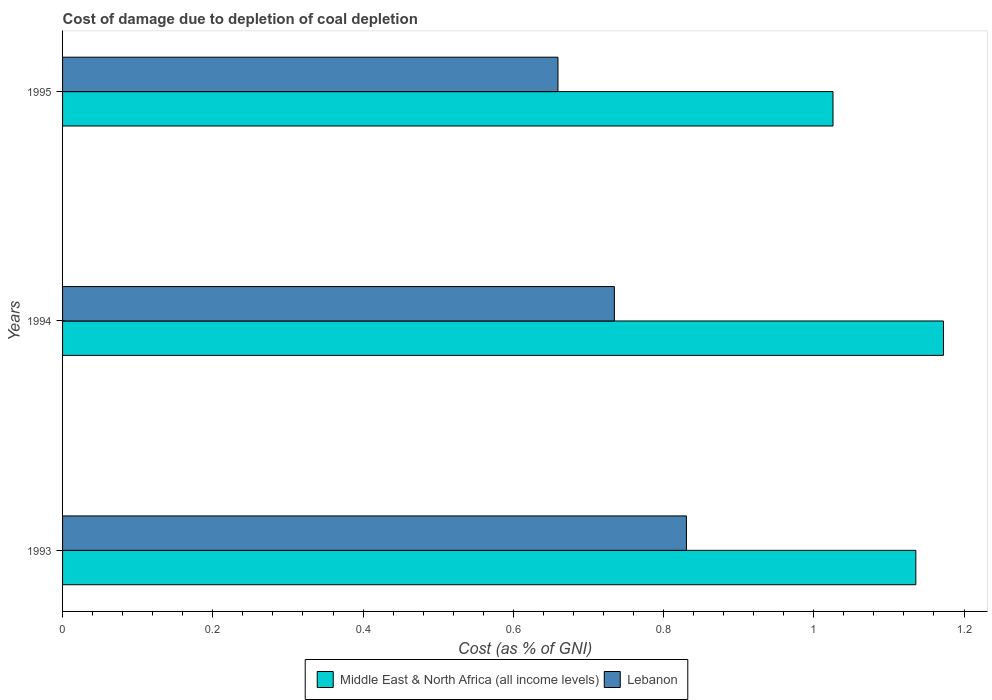How many different coloured bars are there?
Give a very brief answer. 2. How many groups of bars are there?
Make the answer very short. 3. How many bars are there on the 2nd tick from the top?
Provide a short and direct response. 2. What is the label of the 1st group of bars from the top?
Give a very brief answer. 1995. What is the cost of damage caused due to coal depletion in Middle East & North Africa (all income levels) in 1995?
Provide a succinct answer. 1.03. Across all years, what is the maximum cost of damage caused due to coal depletion in Middle East & North Africa (all income levels)?
Offer a very short reply. 1.17. Across all years, what is the minimum cost of damage caused due to coal depletion in Lebanon?
Offer a terse response. 0.66. In which year was the cost of damage caused due to coal depletion in Middle East & North Africa (all income levels) maximum?
Ensure brevity in your answer.  1994. What is the total cost of damage caused due to coal depletion in Middle East & North Africa (all income levels) in the graph?
Your answer should be very brief. 3.33. What is the difference between the cost of damage caused due to coal depletion in Middle East & North Africa (all income levels) in 1994 and that in 1995?
Your response must be concise. 0.15. What is the difference between the cost of damage caused due to coal depletion in Lebanon in 1993 and the cost of damage caused due to coal depletion in Middle East & North Africa (all income levels) in 1994?
Your answer should be compact. -0.34. What is the average cost of damage caused due to coal depletion in Lebanon per year?
Keep it short and to the point. 0.74. In the year 1995, what is the difference between the cost of damage caused due to coal depletion in Middle East & North Africa (all income levels) and cost of damage caused due to coal depletion in Lebanon?
Offer a very short reply. 0.37. What is the ratio of the cost of damage caused due to coal depletion in Middle East & North Africa (all income levels) in 1994 to that in 1995?
Your answer should be compact. 1.14. What is the difference between the highest and the second highest cost of damage caused due to coal depletion in Lebanon?
Keep it short and to the point. 0.1. What is the difference between the highest and the lowest cost of damage caused due to coal depletion in Lebanon?
Keep it short and to the point. 0.17. In how many years, is the cost of damage caused due to coal depletion in Middle East & North Africa (all income levels) greater than the average cost of damage caused due to coal depletion in Middle East & North Africa (all income levels) taken over all years?
Offer a very short reply. 2. What does the 2nd bar from the top in 1995 represents?
Your answer should be very brief. Middle East & North Africa (all income levels). What does the 1st bar from the bottom in 1993 represents?
Give a very brief answer. Middle East & North Africa (all income levels). Are all the bars in the graph horizontal?
Your answer should be very brief. Yes. How many years are there in the graph?
Give a very brief answer. 3. Are the values on the major ticks of X-axis written in scientific E-notation?
Your answer should be very brief. No. Does the graph contain any zero values?
Your response must be concise. No. Where does the legend appear in the graph?
Your answer should be compact. Bottom center. How many legend labels are there?
Keep it short and to the point. 2. What is the title of the graph?
Give a very brief answer. Cost of damage due to depletion of coal depletion. Does "Iceland" appear as one of the legend labels in the graph?
Offer a terse response. No. What is the label or title of the X-axis?
Make the answer very short. Cost (as % of GNI). What is the label or title of the Y-axis?
Your answer should be very brief. Years. What is the Cost (as % of GNI) in Middle East & North Africa (all income levels) in 1993?
Make the answer very short. 1.14. What is the Cost (as % of GNI) in Lebanon in 1993?
Give a very brief answer. 0.83. What is the Cost (as % of GNI) in Middle East & North Africa (all income levels) in 1994?
Keep it short and to the point. 1.17. What is the Cost (as % of GNI) of Lebanon in 1994?
Offer a terse response. 0.73. What is the Cost (as % of GNI) of Middle East & North Africa (all income levels) in 1995?
Your answer should be very brief. 1.03. What is the Cost (as % of GNI) in Lebanon in 1995?
Your answer should be very brief. 0.66. Across all years, what is the maximum Cost (as % of GNI) of Middle East & North Africa (all income levels)?
Your answer should be very brief. 1.17. Across all years, what is the maximum Cost (as % of GNI) in Lebanon?
Give a very brief answer. 0.83. Across all years, what is the minimum Cost (as % of GNI) in Middle East & North Africa (all income levels)?
Keep it short and to the point. 1.03. Across all years, what is the minimum Cost (as % of GNI) in Lebanon?
Offer a terse response. 0.66. What is the total Cost (as % of GNI) in Middle East & North Africa (all income levels) in the graph?
Your answer should be compact. 3.33. What is the total Cost (as % of GNI) of Lebanon in the graph?
Provide a short and direct response. 2.22. What is the difference between the Cost (as % of GNI) in Middle East & North Africa (all income levels) in 1993 and that in 1994?
Keep it short and to the point. -0.04. What is the difference between the Cost (as % of GNI) in Lebanon in 1993 and that in 1994?
Provide a succinct answer. 0.1. What is the difference between the Cost (as % of GNI) in Middle East & North Africa (all income levels) in 1993 and that in 1995?
Offer a very short reply. 0.11. What is the difference between the Cost (as % of GNI) of Lebanon in 1993 and that in 1995?
Make the answer very short. 0.17. What is the difference between the Cost (as % of GNI) in Middle East & North Africa (all income levels) in 1994 and that in 1995?
Provide a succinct answer. 0.15. What is the difference between the Cost (as % of GNI) in Lebanon in 1994 and that in 1995?
Ensure brevity in your answer.  0.08. What is the difference between the Cost (as % of GNI) of Middle East & North Africa (all income levels) in 1993 and the Cost (as % of GNI) of Lebanon in 1994?
Your response must be concise. 0.4. What is the difference between the Cost (as % of GNI) in Middle East & North Africa (all income levels) in 1993 and the Cost (as % of GNI) in Lebanon in 1995?
Keep it short and to the point. 0.48. What is the difference between the Cost (as % of GNI) of Middle East & North Africa (all income levels) in 1994 and the Cost (as % of GNI) of Lebanon in 1995?
Your response must be concise. 0.51. What is the average Cost (as % of GNI) in Middle East & North Africa (all income levels) per year?
Ensure brevity in your answer.  1.11. What is the average Cost (as % of GNI) of Lebanon per year?
Keep it short and to the point. 0.74. In the year 1993, what is the difference between the Cost (as % of GNI) in Middle East & North Africa (all income levels) and Cost (as % of GNI) in Lebanon?
Provide a succinct answer. 0.31. In the year 1994, what is the difference between the Cost (as % of GNI) of Middle East & North Africa (all income levels) and Cost (as % of GNI) of Lebanon?
Offer a terse response. 0.44. In the year 1995, what is the difference between the Cost (as % of GNI) of Middle East & North Africa (all income levels) and Cost (as % of GNI) of Lebanon?
Offer a terse response. 0.37. What is the ratio of the Cost (as % of GNI) in Middle East & North Africa (all income levels) in 1993 to that in 1994?
Offer a terse response. 0.97. What is the ratio of the Cost (as % of GNI) in Lebanon in 1993 to that in 1994?
Your answer should be very brief. 1.13. What is the ratio of the Cost (as % of GNI) in Middle East & North Africa (all income levels) in 1993 to that in 1995?
Your response must be concise. 1.11. What is the ratio of the Cost (as % of GNI) of Lebanon in 1993 to that in 1995?
Give a very brief answer. 1.26. What is the ratio of the Cost (as % of GNI) of Middle East & North Africa (all income levels) in 1994 to that in 1995?
Give a very brief answer. 1.14. What is the ratio of the Cost (as % of GNI) in Lebanon in 1994 to that in 1995?
Offer a very short reply. 1.11. What is the difference between the highest and the second highest Cost (as % of GNI) in Middle East & North Africa (all income levels)?
Ensure brevity in your answer.  0.04. What is the difference between the highest and the second highest Cost (as % of GNI) in Lebanon?
Your response must be concise. 0.1. What is the difference between the highest and the lowest Cost (as % of GNI) of Middle East & North Africa (all income levels)?
Ensure brevity in your answer.  0.15. What is the difference between the highest and the lowest Cost (as % of GNI) in Lebanon?
Your answer should be very brief. 0.17. 